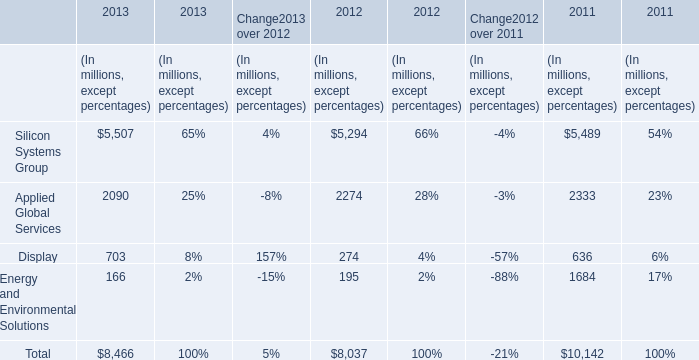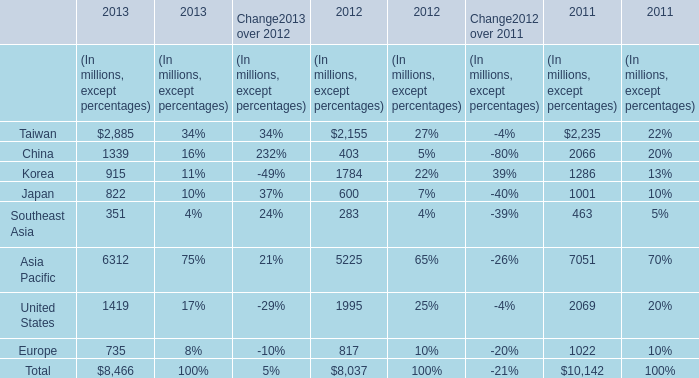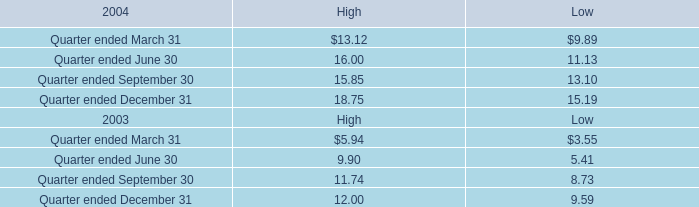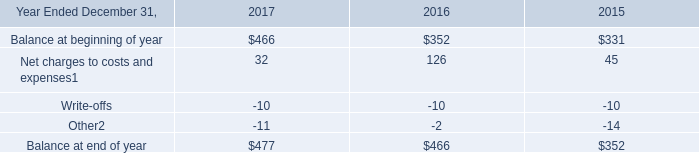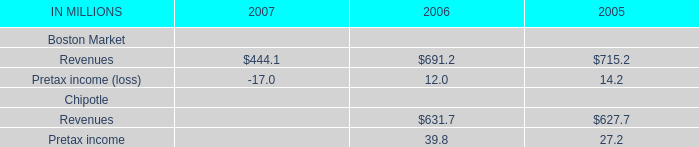If Display develops with the same growth rate in 2013, what will it reach in 2014? (in million) 
Computations: ((1 + ((703 - 274) / 274)) * 703)
Answer: 1803.68248. 